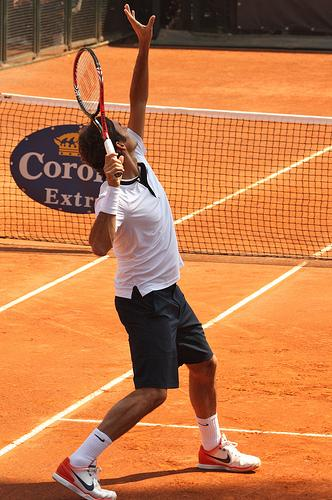What is one unique feature about the tennis court in the image? The tennis court has a black fence surrounding it. Describe the man's attire while playing tennis in the image. The man is wearing a white shirt, dark shorts, white and black socks, and red and white Nike tennis shoes. What is the prominent brand visible in the image related to the tennis player's attire? The prominent brand visible in the image is Nike. What kind of footwear is the man wearing, and what are the dominant colors? The man is wearing red and white Nike tennis shoes. How many tennis racquets can you see in the image, and what colors are they? There is one tennis racquet, which is red, orange, and black in color. Identify the type of sports-related activity taking place in the image. The image depicts a man playing tennis on a clay court. What is advertised on the blue, white, and orange sign visible in the image? The sign advertises Corona Extra. What type of court is the tennis game being played on? The game is being played on a clay court. Count the total number of white lines present on the tennis court. There are multiple white lines on the tennis court, making it difficult to count the exact number. What is the purpose of the white wrist band the man is wearing? The white wrist band serves to absorb sweat and provide support to the man's wrist during the game. Isn't it fascinating how the tennis ball is suspended in mid-air? There is no mention of a tennis ball in the image. This instruction is misleading by creating an imaginary scene with a new object (tennis ball) that doesn't exist in the actual image. Can you find the purple hat on the tennis player's head? There is no mention of a hat or an object with a purple color in the image. This instruction creates confusion by suggesting there is a non-existent object. Find the woman cheering in the background of the image. There is no mention of a woman, cheering, or background in the image. This instruction confuses the viewer by suggesting an entirely new character and event that is not present in the image. Can you see the dog sitting next to the black fence, watching the tennis game intently? No, it's not mentioned in the image. Notice the green water bottle next to the tennis court. There is no mention of a water bottle or any object with a green color in the image. This instruction misleads by introducing a new object that doesn't exist and is unrelated to the true image content. 